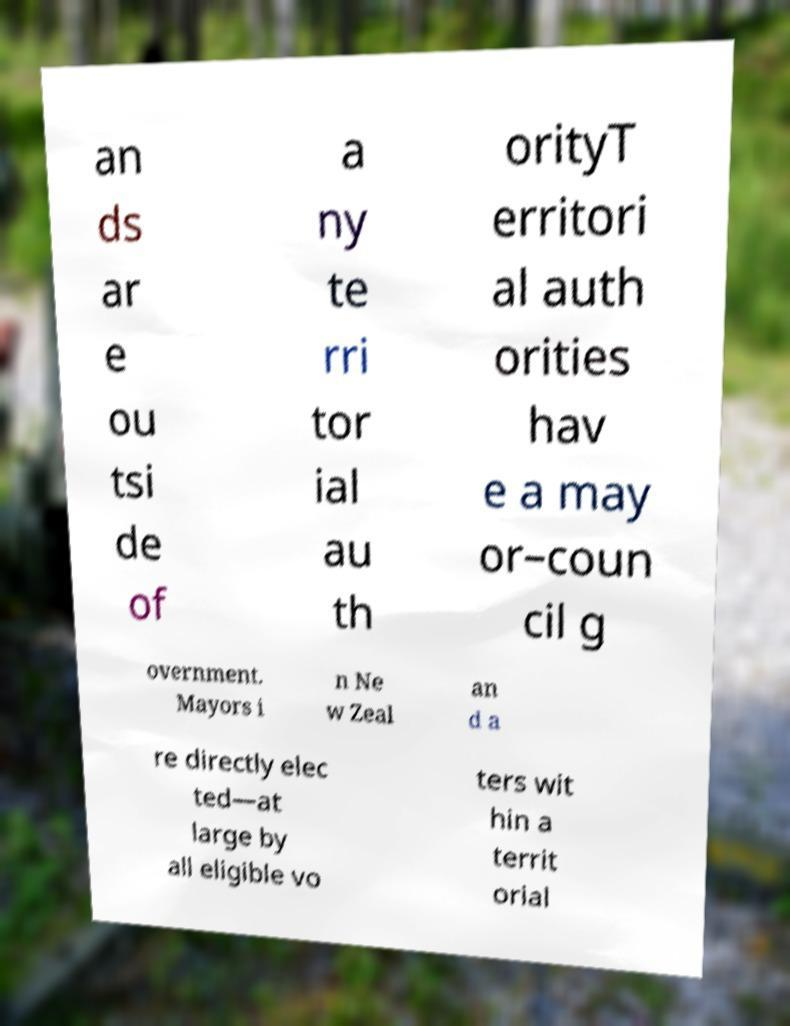Can you accurately transcribe the text from the provided image for me? an ds ar e ou tsi de of a ny te rri tor ial au th orityT erritori al auth orities hav e a may or–coun cil g overnment. Mayors i n Ne w Zeal an d a re directly elec ted—at large by all eligible vo ters wit hin a territ orial 